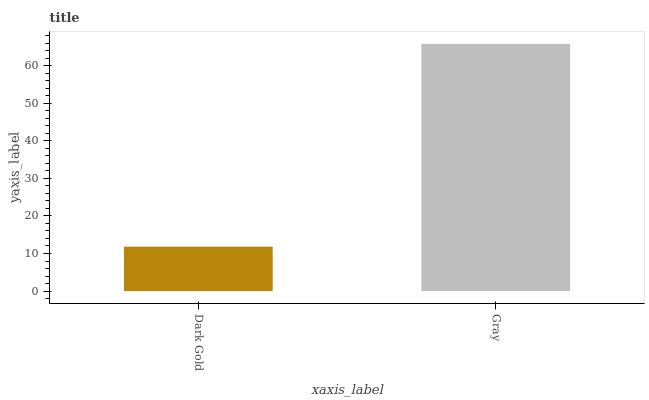Is Dark Gold the minimum?
Answer yes or no. Yes. Is Gray the maximum?
Answer yes or no. Yes. Is Gray the minimum?
Answer yes or no. No. Is Gray greater than Dark Gold?
Answer yes or no. Yes. Is Dark Gold less than Gray?
Answer yes or no. Yes. Is Dark Gold greater than Gray?
Answer yes or no. No. Is Gray less than Dark Gold?
Answer yes or no. No. Is Gray the high median?
Answer yes or no. Yes. Is Dark Gold the low median?
Answer yes or no. Yes. Is Dark Gold the high median?
Answer yes or no. No. Is Gray the low median?
Answer yes or no. No. 